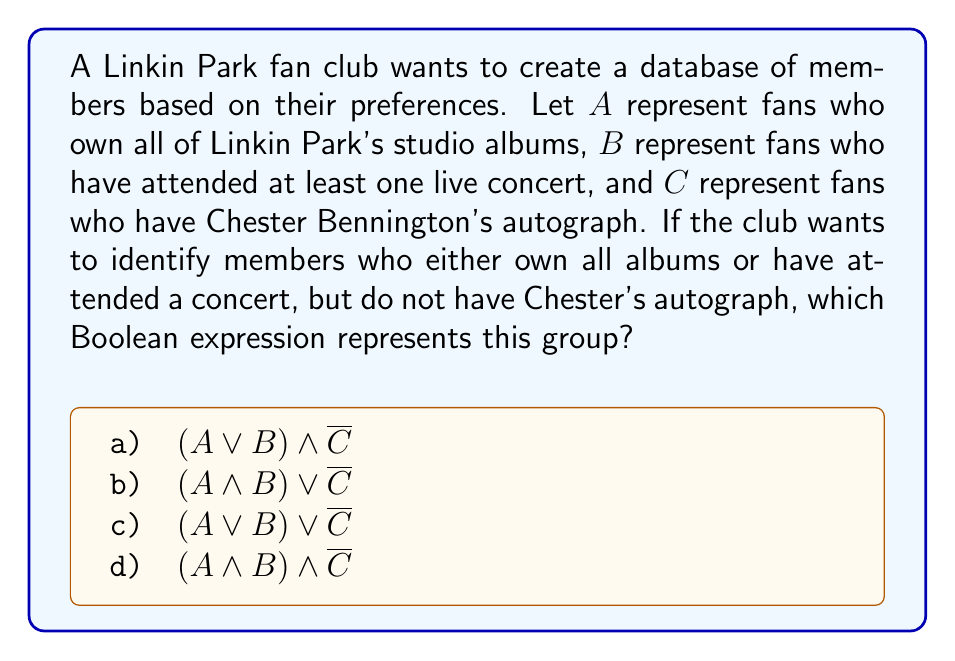Show me your answer to this math problem. Let's break down the problem step-by-step:

1) We need to represent fans who:
   - Own all albums OR have attended a concert
   - Do NOT have Chester's autograph

2) Let's start with the first condition:
   - Own all albums OR have attended a concert
   - This is represented by $(A \lor B)$

3) For the second condition:
   - Do NOT have Chester's autograph
   - This is represented by $\overline{C}$ (the complement of C)

4) We want fans who satisfy BOTH of these conditions:
   - (Own all albums OR have attended a concert) AND (Do NOT have Chester's autograph)
   - This is represented by combining the expressions from steps 2 and 3 with AND:
     $(A \lor B) \land \overline{C}$

5) Looking at the given options, we can see that this matches option a).

Therefore, the correct Boolean expression is $(A \lor B) \land \overline{C}$.
Answer: $(A \lor B) \land \overline{C}$ 